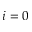<formula> <loc_0><loc_0><loc_500><loc_500>i = 0</formula> 